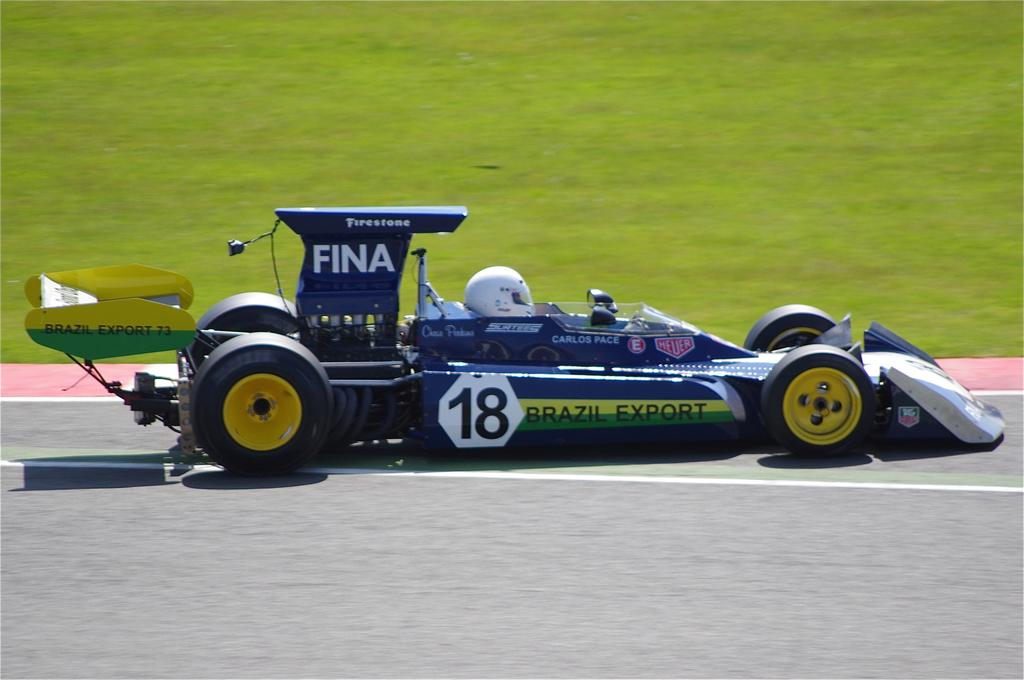What type of vehicle is in the image? There is a sports car in the image. Who is inside the sports car? A person is sitting in the sports car. What can be seen on the sports car? There is writing on the sports car. What is the setting of the image? The image shows a road. What type of vegetation is visible in the background? There is grass visible in the background of the image. What type of pancake is the person eating in the image? There is no pancake present in the image; the person is sitting in a sports car. Is there a maid in the image? There is no mention of a maid in the image; it features a sports car with a person sitting inside. 